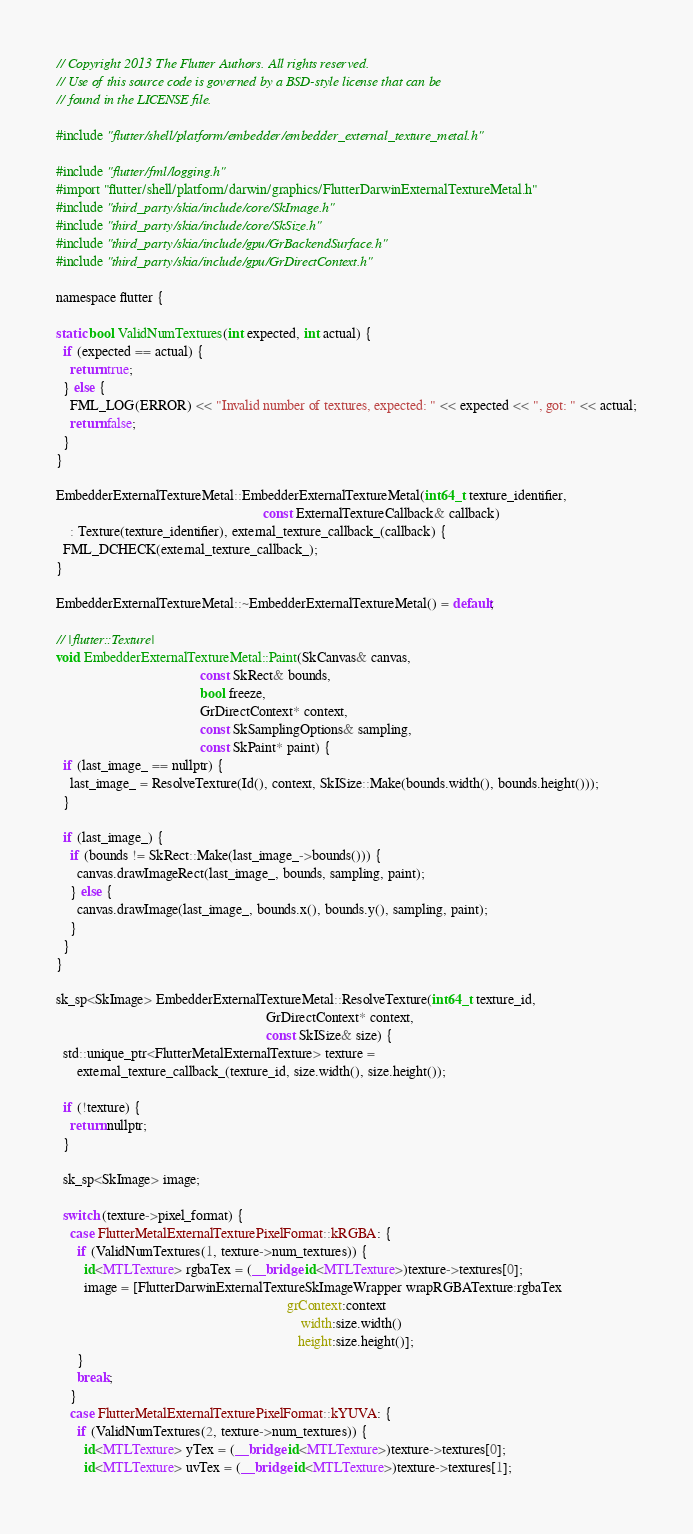<code> <loc_0><loc_0><loc_500><loc_500><_ObjectiveC_>// Copyright 2013 The Flutter Authors. All rights reserved.
// Use of this source code is governed by a BSD-style license that can be
// found in the LICENSE file.

#include "flutter/shell/platform/embedder/embedder_external_texture_metal.h"

#include "flutter/fml/logging.h"
#import "flutter/shell/platform/darwin/graphics/FlutterDarwinExternalTextureMetal.h"
#include "third_party/skia/include/core/SkImage.h"
#include "third_party/skia/include/core/SkSize.h"
#include "third_party/skia/include/gpu/GrBackendSurface.h"
#include "third_party/skia/include/gpu/GrDirectContext.h"

namespace flutter {

static bool ValidNumTextures(int expected, int actual) {
  if (expected == actual) {
    return true;
  } else {
    FML_LOG(ERROR) << "Invalid number of textures, expected: " << expected << ", got: " << actual;
    return false;
  }
}

EmbedderExternalTextureMetal::EmbedderExternalTextureMetal(int64_t texture_identifier,
                                                           const ExternalTextureCallback& callback)
    : Texture(texture_identifier), external_texture_callback_(callback) {
  FML_DCHECK(external_texture_callback_);
}

EmbedderExternalTextureMetal::~EmbedderExternalTextureMetal() = default;

// |flutter::Texture|
void EmbedderExternalTextureMetal::Paint(SkCanvas& canvas,
                                         const SkRect& bounds,
                                         bool freeze,
                                         GrDirectContext* context,
                                         const SkSamplingOptions& sampling,
                                         const SkPaint* paint) {
  if (last_image_ == nullptr) {
    last_image_ = ResolveTexture(Id(), context, SkISize::Make(bounds.width(), bounds.height()));
  }

  if (last_image_) {
    if (bounds != SkRect::Make(last_image_->bounds())) {
      canvas.drawImageRect(last_image_, bounds, sampling, paint);
    } else {
      canvas.drawImage(last_image_, bounds.x(), bounds.y(), sampling, paint);
    }
  }
}

sk_sp<SkImage> EmbedderExternalTextureMetal::ResolveTexture(int64_t texture_id,
                                                            GrDirectContext* context,
                                                            const SkISize& size) {
  std::unique_ptr<FlutterMetalExternalTexture> texture =
      external_texture_callback_(texture_id, size.width(), size.height());

  if (!texture) {
    return nullptr;
  }

  sk_sp<SkImage> image;

  switch (texture->pixel_format) {
    case FlutterMetalExternalTexturePixelFormat::kRGBA: {
      if (ValidNumTextures(1, texture->num_textures)) {
        id<MTLTexture> rgbaTex = (__bridge id<MTLTexture>)texture->textures[0];
        image = [FlutterDarwinExternalTextureSkImageWrapper wrapRGBATexture:rgbaTex
                                                                  grContext:context
                                                                      width:size.width()
                                                                     height:size.height()];
      }
      break;
    }
    case FlutterMetalExternalTexturePixelFormat::kYUVA: {
      if (ValidNumTextures(2, texture->num_textures)) {
        id<MTLTexture> yTex = (__bridge id<MTLTexture>)texture->textures[0];
        id<MTLTexture> uvTex = (__bridge id<MTLTexture>)texture->textures[1];</code> 